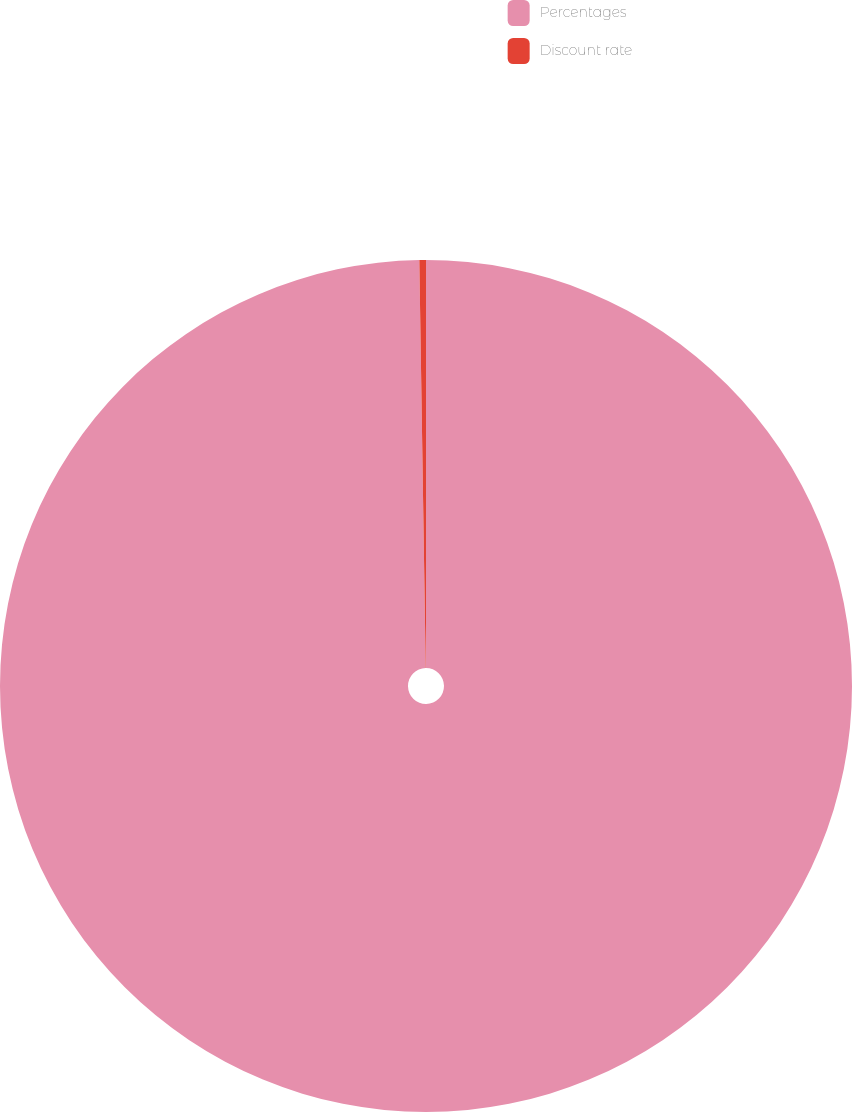Convert chart. <chart><loc_0><loc_0><loc_500><loc_500><pie_chart><fcel>Percentages<fcel>Discount rate<nl><fcel>99.75%<fcel>0.25%<nl></chart> 